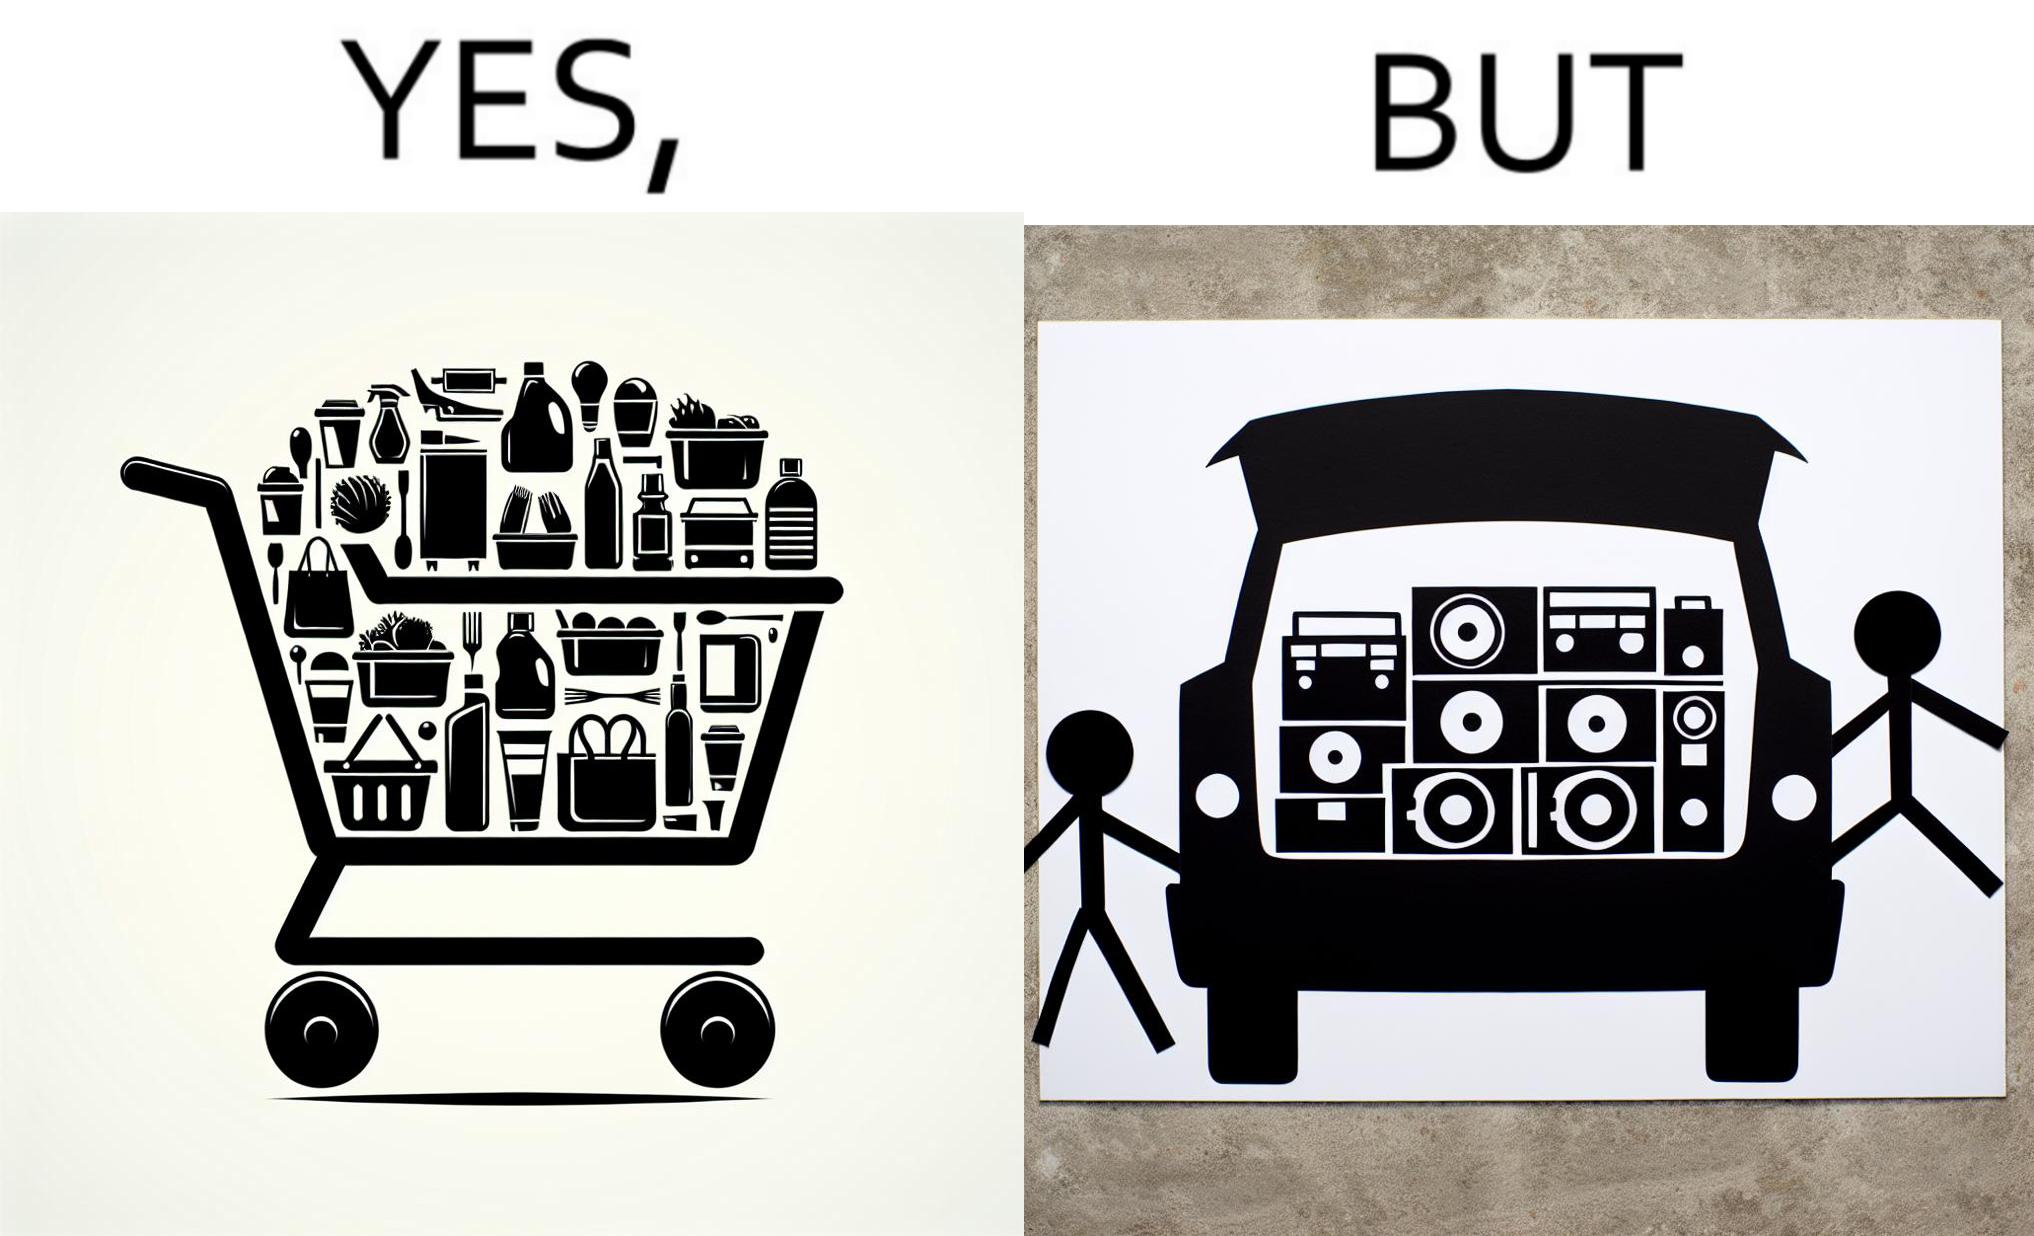Describe the content of this image. The image is ironic, because a car trunk was earlier designed to keep some extra luggage or things but people nowadays get speakers installed in the trunk which in turn reduces the space in the trunk and making it difficult for people to store the extra luggage in the trunk 